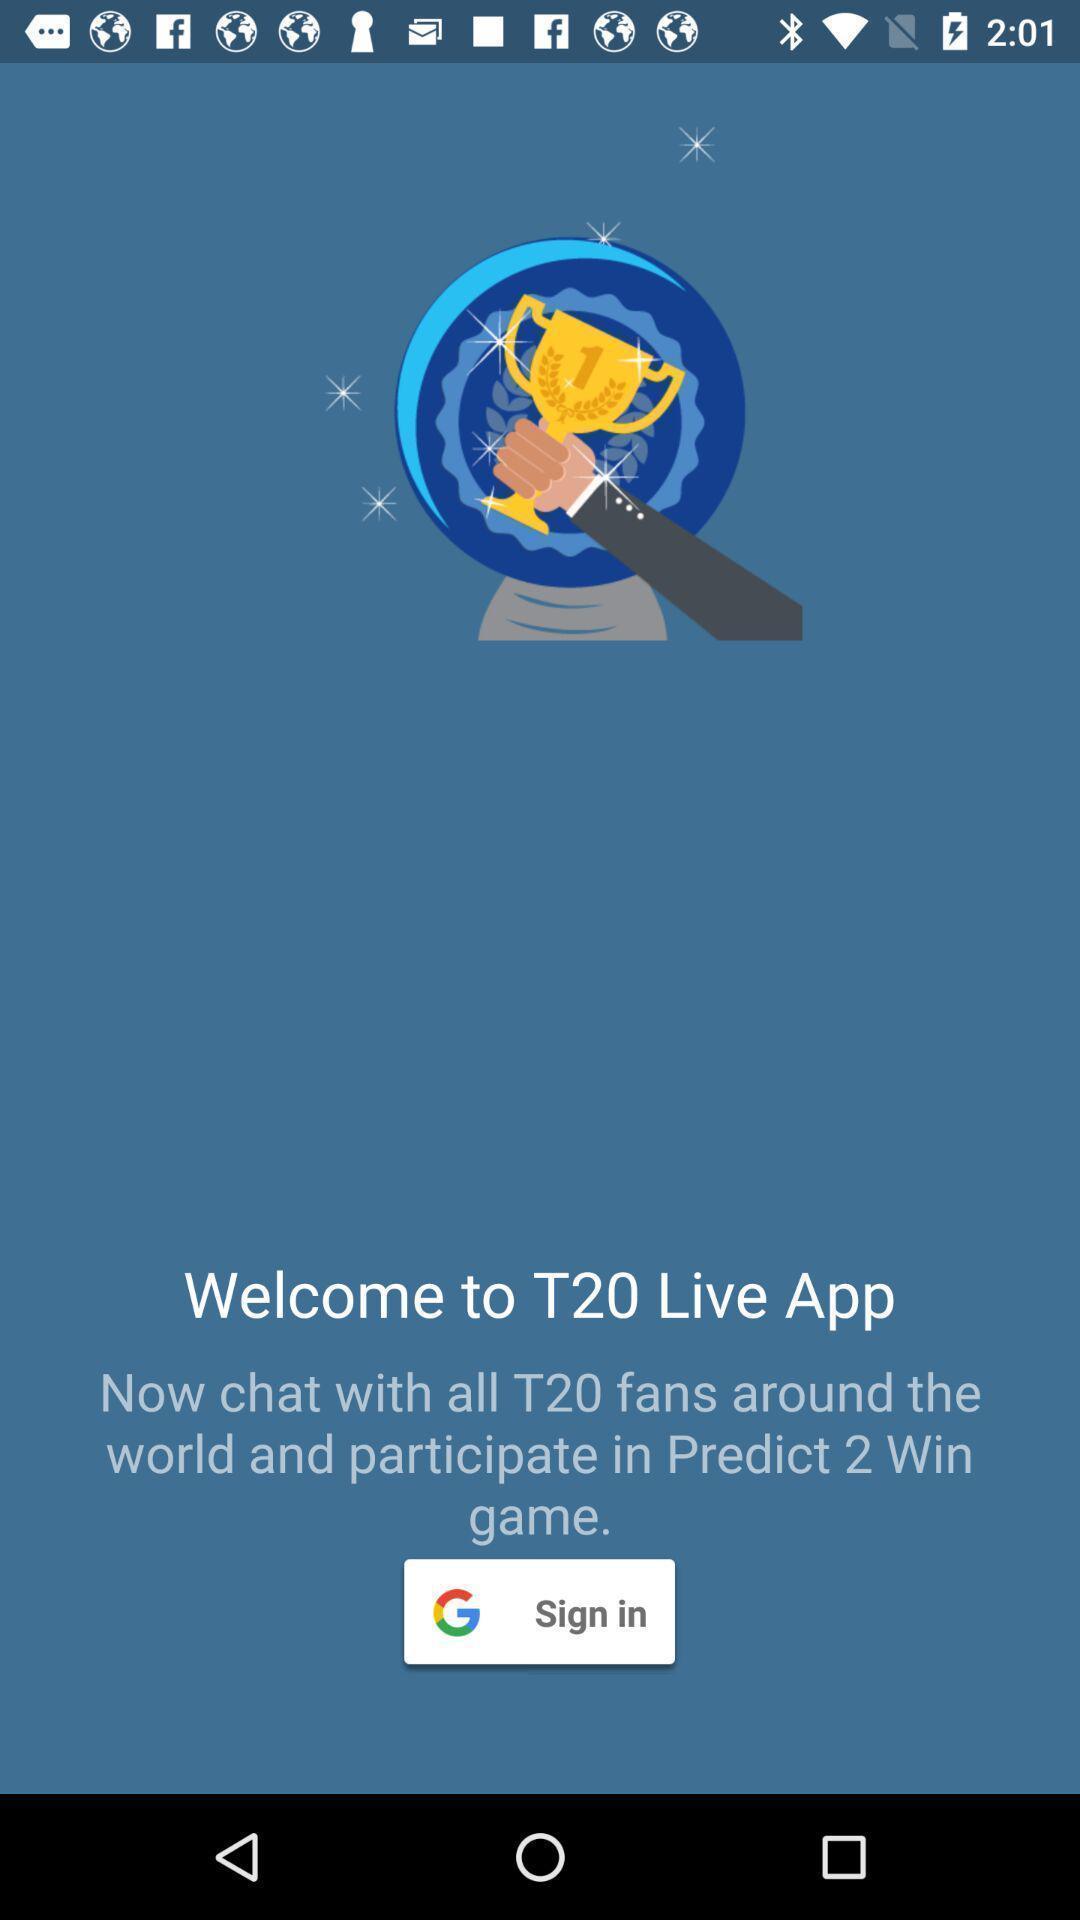Provide a description of this screenshot. Welcome page. 